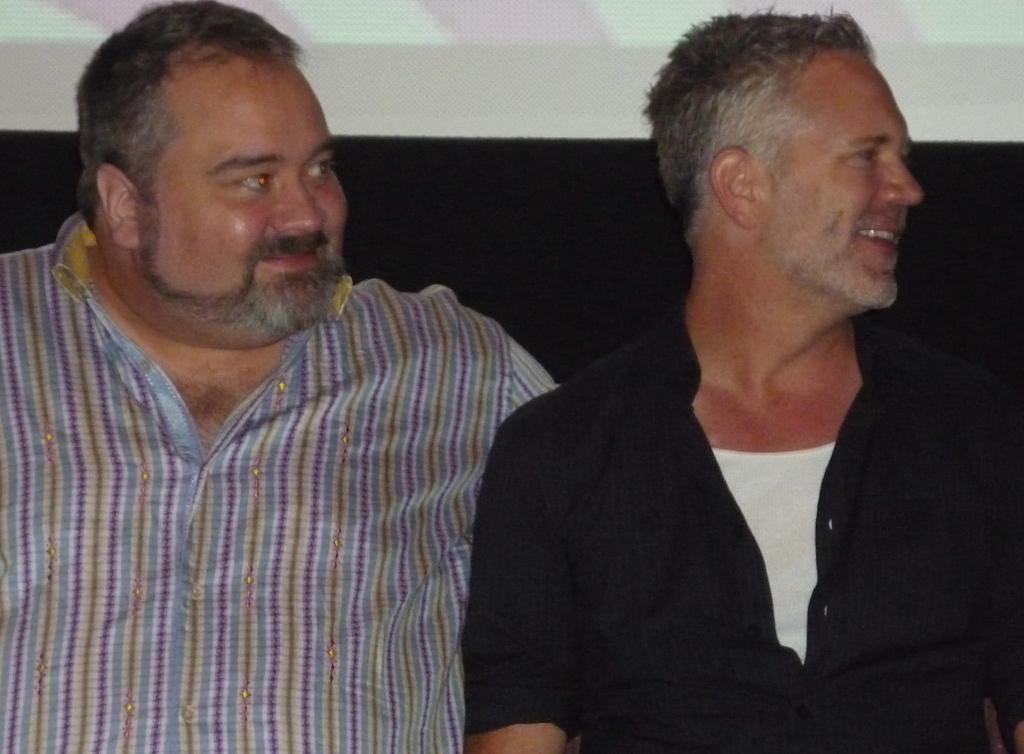How would you summarize this image in a sentence or two? In this picture we can see me, it seems like they are sitting. They both are smiling. 